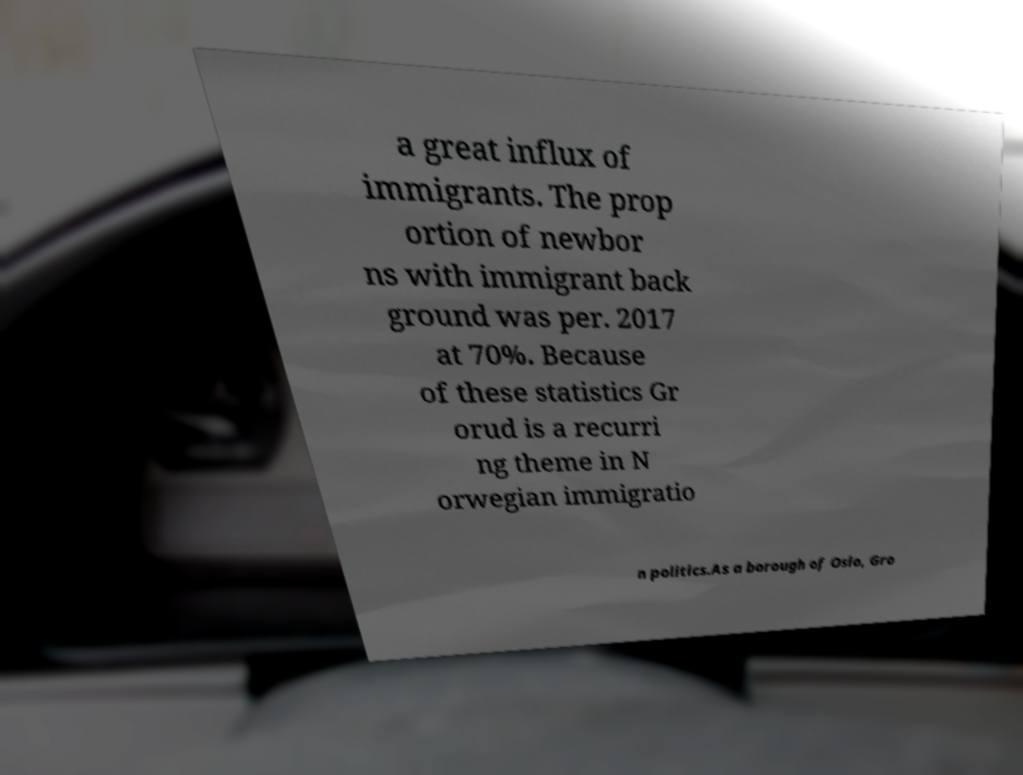I need the written content from this picture converted into text. Can you do that? a great influx of immigrants. The prop ortion of newbor ns with immigrant back ground was per. 2017 at 70%. Because of these statistics Gr orud is a recurri ng theme in N orwegian immigratio n politics.As a borough of Oslo, Gro 